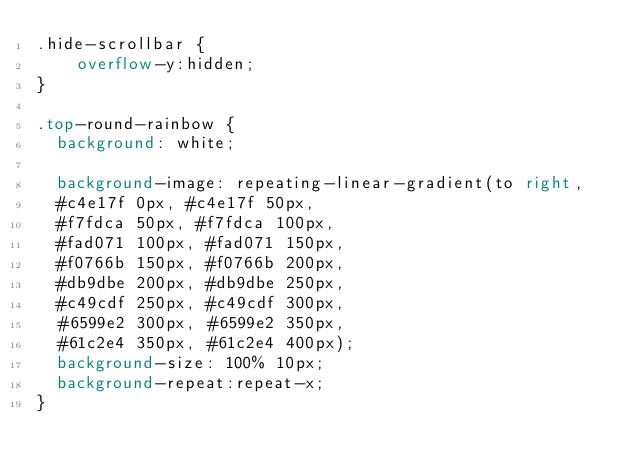Convert code to text. <code><loc_0><loc_0><loc_500><loc_500><_CSS_>.hide-scrollbar {
    overflow-y:hidden;
}

.top-round-rainbow {
  background: white;
  
  background-image: repeating-linear-gradient(to right,
  #c4e17f 0px, #c4e17f 50px,
  #f7fdca 50px, #f7fdca 100px,
  #fad071 100px, #fad071 150px,
  #f0766b 150px, #f0766b 200px,
  #db9dbe 200px, #db9dbe 250px,
  #c49cdf 250px, #c49cdf 300px,
  #6599e2 300px, #6599e2 350px,
  #61c2e4 350px, #61c2e4 400px);
  background-size: 100% 10px;
  background-repeat:repeat-x;
}</code> 